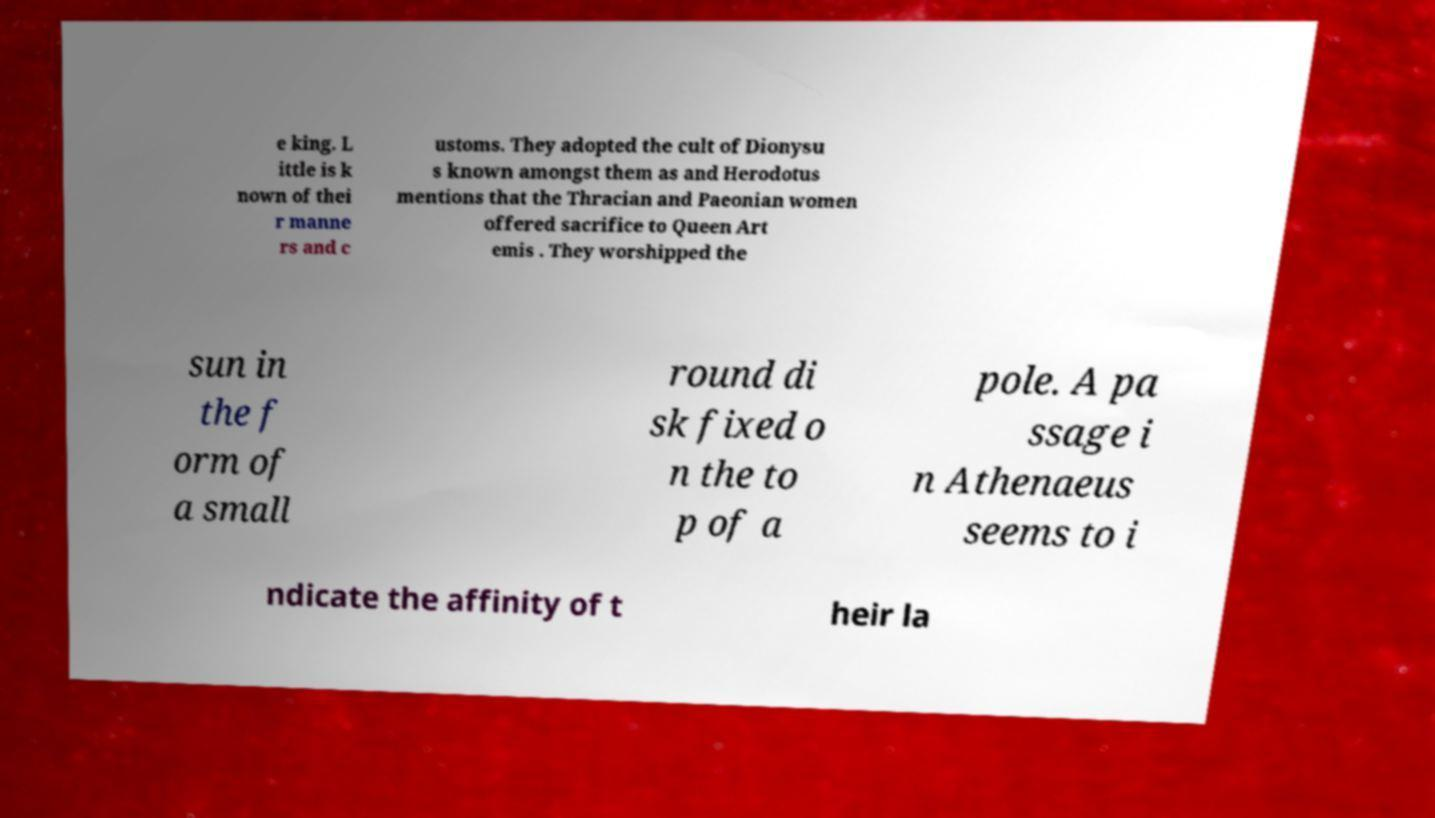Can you accurately transcribe the text from the provided image for me? e king. L ittle is k nown of thei r manne rs and c ustoms. They adopted the cult of Dionysu s known amongst them as and Herodotus mentions that the Thracian and Paeonian women offered sacrifice to Queen Art emis . They worshipped the sun in the f orm of a small round di sk fixed o n the to p of a pole. A pa ssage i n Athenaeus seems to i ndicate the affinity of t heir la 